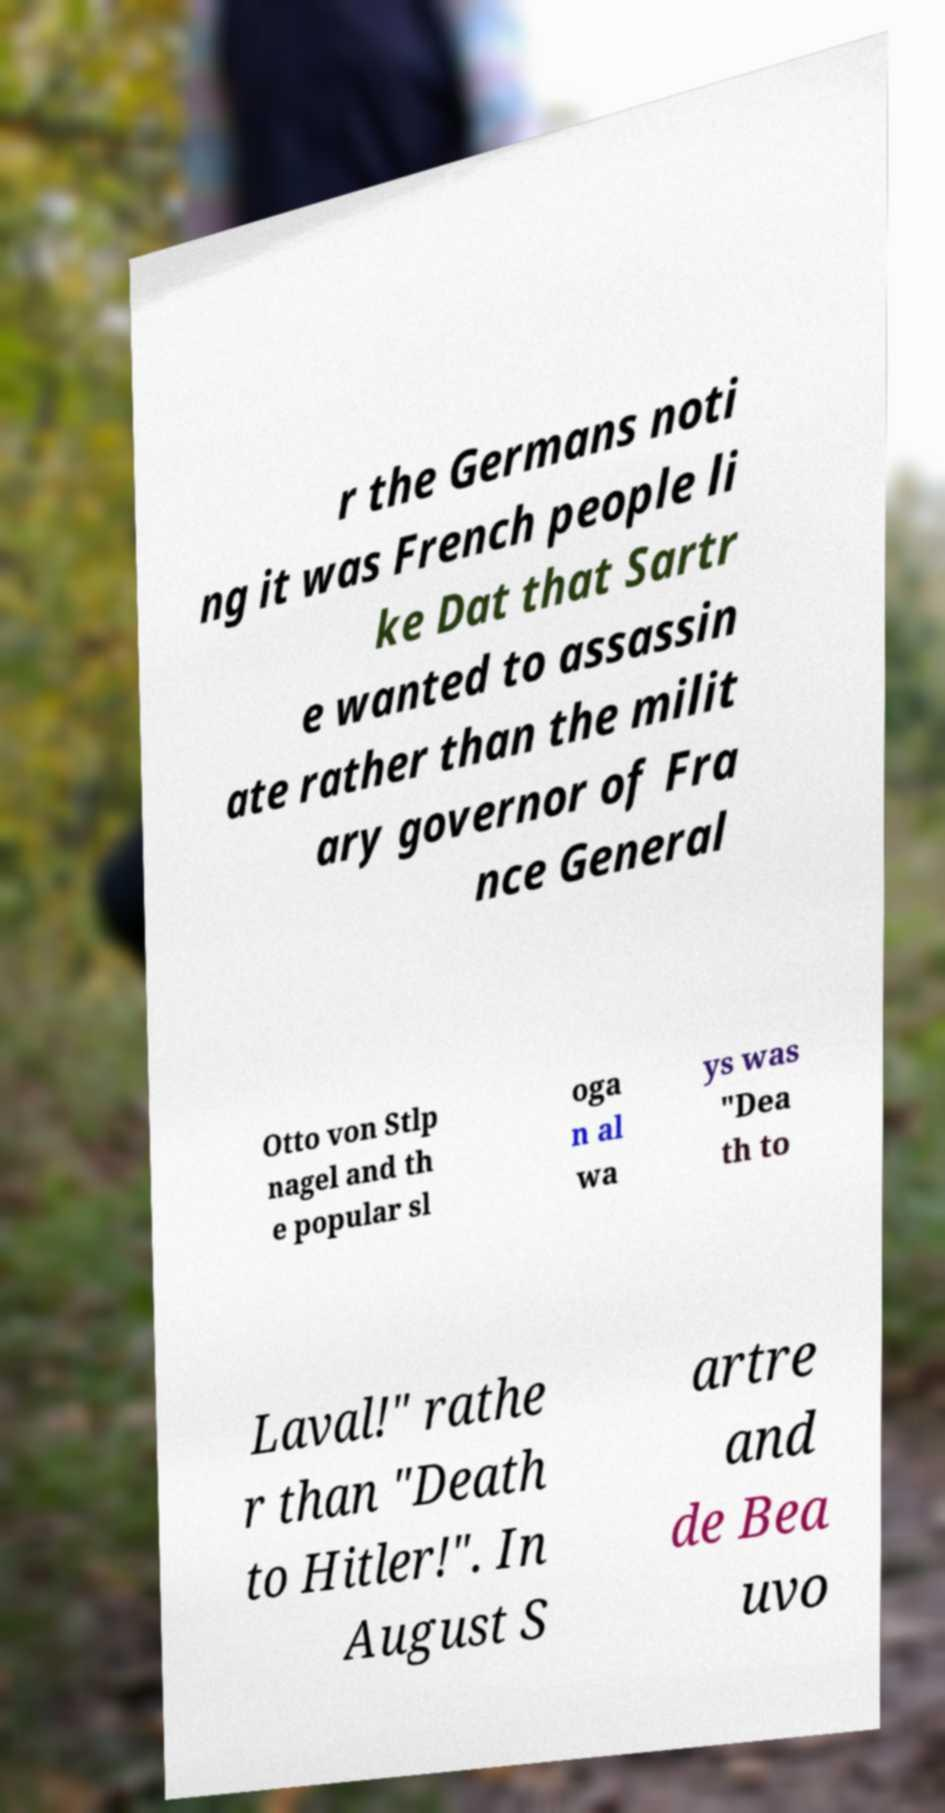Can you accurately transcribe the text from the provided image for me? r the Germans noti ng it was French people li ke Dat that Sartr e wanted to assassin ate rather than the milit ary governor of Fra nce General Otto von Stlp nagel and th e popular sl oga n al wa ys was "Dea th to Laval!" rathe r than "Death to Hitler!". In August S artre and de Bea uvo 